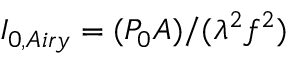Convert formula to latex. <formula><loc_0><loc_0><loc_500><loc_500>I _ { 0 , A i r y } = ( P _ { 0 } A ) / ( \lambda ^ { 2 } f ^ { 2 } )</formula> 